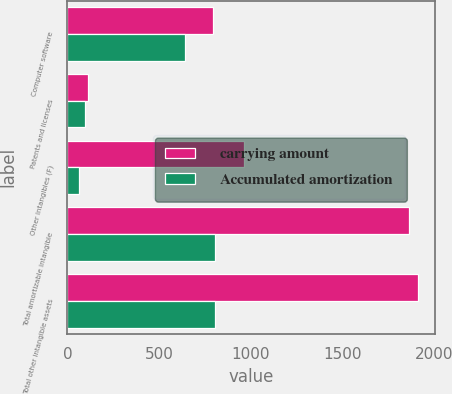Convert chart to OTSL. <chart><loc_0><loc_0><loc_500><loc_500><stacked_bar_chart><ecel><fcel>Computer software<fcel>Patents and licenses<fcel>Other intangibles (F)<fcel>Total amortizable intangible<fcel>Total other intangible assets<nl><fcel>carrying amount<fcel>793<fcel>110<fcel>961<fcel>1864<fcel>1909<nl><fcel>Accumulated amortization<fcel>643<fcel>98<fcel>64<fcel>805<fcel>805<nl></chart> 